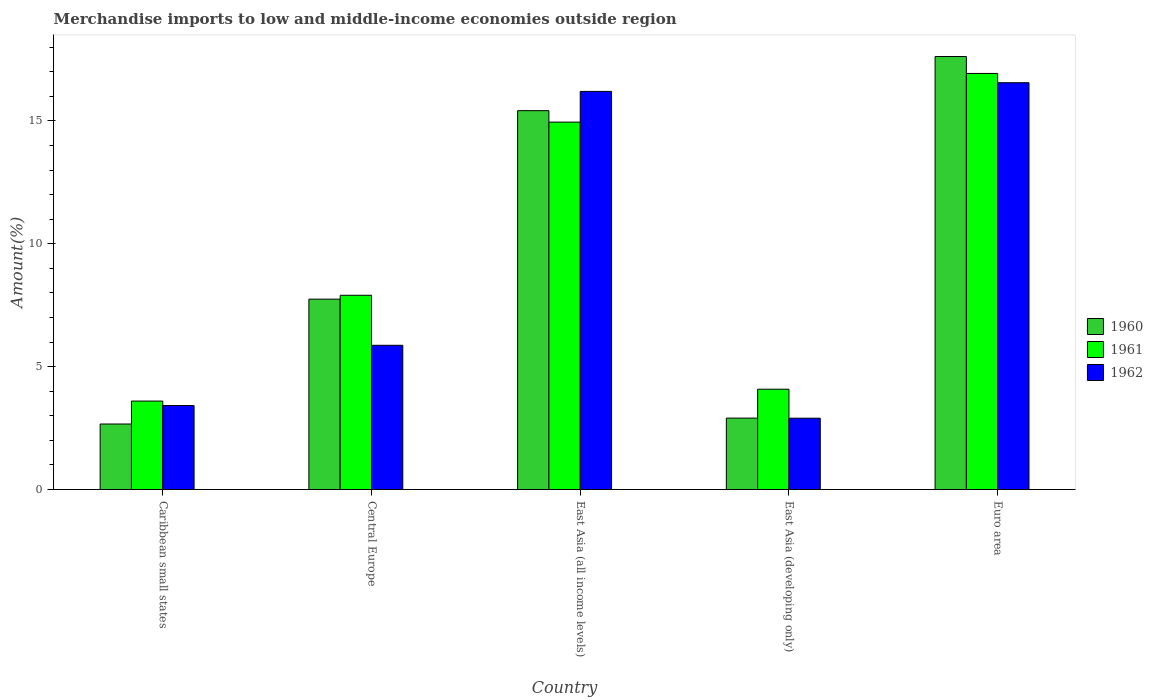How many different coloured bars are there?
Make the answer very short. 3. How many groups of bars are there?
Provide a succinct answer. 5. Are the number of bars per tick equal to the number of legend labels?
Offer a terse response. Yes. Are the number of bars on each tick of the X-axis equal?
Your answer should be very brief. Yes. How many bars are there on the 4th tick from the left?
Keep it short and to the point. 3. How many bars are there on the 3rd tick from the right?
Offer a terse response. 3. What is the label of the 3rd group of bars from the left?
Offer a very short reply. East Asia (all income levels). What is the percentage of amount earned from merchandise imports in 1962 in East Asia (all income levels)?
Offer a very short reply. 16.2. Across all countries, what is the maximum percentage of amount earned from merchandise imports in 1961?
Offer a very short reply. 16.93. Across all countries, what is the minimum percentage of amount earned from merchandise imports in 1960?
Give a very brief answer. 2.67. In which country was the percentage of amount earned from merchandise imports in 1960 minimum?
Provide a short and direct response. Caribbean small states. What is the total percentage of amount earned from merchandise imports in 1961 in the graph?
Offer a very short reply. 47.46. What is the difference between the percentage of amount earned from merchandise imports in 1960 in Caribbean small states and that in East Asia (all income levels)?
Provide a succinct answer. -12.75. What is the difference between the percentage of amount earned from merchandise imports in 1961 in East Asia (developing only) and the percentage of amount earned from merchandise imports in 1962 in East Asia (all income levels)?
Ensure brevity in your answer.  -12.12. What is the average percentage of amount earned from merchandise imports in 1961 per country?
Provide a succinct answer. 9.49. What is the difference between the percentage of amount earned from merchandise imports of/in 1962 and percentage of amount earned from merchandise imports of/in 1961 in East Asia (developing only)?
Provide a short and direct response. -1.18. What is the ratio of the percentage of amount earned from merchandise imports in 1962 in East Asia (developing only) to that in Euro area?
Provide a succinct answer. 0.18. Is the percentage of amount earned from merchandise imports in 1960 in Caribbean small states less than that in East Asia (all income levels)?
Offer a very short reply. Yes. Is the difference between the percentage of amount earned from merchandise imports in 1962 in Caribbean small states and Central Europe greater than the difference between the percentage of amount earned from merchandise imports in 1961 in Caribbean small states and Central Europe?
Provide a short and direct response. Yes. What is the difference between the highest and the second highest percentage of amount earned from merchandise imports in 1962?
Your response must be concise. 0.35. What is the difference between the highest and the lowest percentage of amount earned from merchandise imports in 1960?
Make the answer very short. 14.95. What does the 2nd bar from the right in Central Europe represents?
Keep it short and to the point. 1961. Is it the case that in every country, the sum of the percentage of amount earned from merchandise imports in 1960 and percentage of amount earned from merchandise imports in 1962 is greater than the percentage of amount earned from merchandise imports in 1961?
Provide a short and direct response. Yes. How many bars are there?
Provide a succinct answer. 15. What is the difference between two consecutive major ticks on the Y-axis?
Ensure brevity in your answer.  5. How are the legend labels stacked?
Offer a terse response. Vertical. What is the title of the graph?
Keep it short and to the point. Merchandise imports to low and middle-income economies outside region. Does "2006" appear as one of the legend labels in the graph?
Make the answer very short. No. What is the label or title of the Y-axis?
Provide a succinct answer. Amount(%). What is the Amount(%) of 1960 in Caribbean small states?
Offer a terse response. 2.67. What is the Amount(%) in 1961 in Caribbean small states?
Your answer should be very brief. 3.6. What is the Amount(%) of 1962 in Caribbean small states?
Give a very brief answer. 3.42. What is the Amount(%) of 1960 in Central Europe?
Ensure brevity in your answer.  7.75. What is the Amount(%) in 1961 in Central Europe?
Make the answer very short. 7.9. What is the Amount(%) in 1962 in Central Europe?
Give a very brief answer. 5.87. What is the Amount(%) of 1960 in East Asia (all income levels)?
Make the answer very short. 15.41. What is the Amount(%) of 1961 in East Asia (all income levels)?
Your response must be concise. 14.95. What is the Amount(%) of 1962 in East Asia (all income levels)?
Your response must be concise. 16.2. What is the Amount(%) of 1960 in East Asia (developing only)?
Keep it short and to the point. 2.91. What is the Amount(%) in 1961 in East Asia (developing only)?
Your answer should be very brief. 4.08. What is the Amount(%) of 1962 in East Asia (developing only)?
Provide a succinct answer. 2.9. What is the Amount(%) of 1960 in Euro area?
Provide a short and direct response. 17.62. What is the Amount(%) in 1961 in Euro area?
Your answer should be compact. 16.93. What is the Amount(%) in 1962 in Euro area?
Give a very brief answer. 16.55. Across all countries, what is the maximum Amount(%) of 1960?
Provide a short and direct response. 17.62. Across all countries, what is the maximum Amount(%) in 1961?
Ensure brevity in your answer.  16.93. Across all countries, what is the maximum Amount(%) in 1962?
Give a very brief answer. 16.55. Across all countries, what is the minimum Amount(%) in 1960?
Offer a very short reply. 2.67. Across all countries, what is the minimum Amount(%) of 1961?
Make the answer very short. 3.6. Across all countries, what is the minimum Amount(%) of 1962?
Offer a very short reply. 2.9. What is the total Amount(%) of 1960 in the graph?
Offer a very short reply. 46.35. What is the total Amount(%) in 1961 in the graph?
Your answer should be compact. 47.46. What is the total Amount(%) in 1962 in the graph?
Offer a very short reply. 44.94. What is the difference between the Amount(%) in 1960 in Caribbean small states and that in Central Europe?
Your answer should be compact. -5.08. What is the difference between the Amount(%) of 1961 in Caribbean small states and that in Central Europe?
Provide a succinct answer. -4.3. What is the difference between the Amount(%) of 1962 in Caribbean small states and that in Central Europe?
Provide a succinct answer. -2.45. What is the difference between the Amount(%) of 1960 in Caribbean small states and that in East Asia (all income levels)?
Make the answer very short. -12.75. What is the difference between the Amount(%) of 1961 in Caribbean small states and that in East Asia (all income levels)?
Your response must be concise. -11.35. What is the difference between the Amount(%) of 1962 in Caribbean small states and that in East Asia (all income levels)?
Ensure brevity in your answer.  -12.78. What is the difference between the Amount(%) in 1960 in Caribbean small states and that in East Asia (developing only)?
Your answer should be compact. -0.24. What is the difference between the Amount(%) of 1961 in Caribbean small states and that in East Asia (developing only)?
Give a very brief answer. -0.48. What is the difference between the Amount(%) in 1962 in Caribbean small states and that in East Asia (developing only)?
Make the answer very short. 0.52. What is the difference between the Amount(%) of 1960 in Caribbean small states and that in Euro area?
Provide a succinct answer. -14.95. What is the difference between the Amount(%) in 1961 in Caribbean small states and that in Euro area?
Offer a terse response. -13.33. What is the difference between the Amount(%) in 1962 in Caribbean small states and that in Euro area?
Provide a succinct answer. -13.13. What is the difference between the Amount(%) in 1960 in Central Europe and that in East Asia (all income levels)?
Provide a succinct answer. -7.67. What is the difference between the Amount(%) of 1961 in Central Europe and that in East Asia (all income levels)?
Keep it short and to the point. -7.05. What is the difference between the Amount(%) of 1962 in Central Europe and that in East Asia (all income levels)?
Offer a very short reply. -10.33. What is the difference between the Amount(%) in 1960 in Central Europe and that in East Asia (developing only)?
Your response must be concise. 4.84. What is the difference between the Amount(%) in 1961 in Central Europe and that in East Asia (developing only)?
Offer a very short reply. 3.82. What is the difference between the Amount(%) in 1962 in Central Europe and that in East Asia (developing only)?
Your answer should be compact. 2.97. What is the difference between the Amount(%) of 1960 in Central Europe and that in Euro area?
Provide a succinct answer. -9.87. What is the difference between the Amount(%) of 1961 in Central Europe and that in Euro area?
Ensure brevity in your answer.  -9.03. What is the difference between the Amount(%) in 1962 in Central Europe and that in Euro area?
Ensure brevity in your answer.  -10.68. What is the difference between the Amount(%) in 1960 in East Asia (all income levels) and that in East Asia (developing only)?
Provide a short and direct response. 12.51. What is the difference between the Amount(%) in 1961 in East Asia (all income levels) and that in East Asia (developing only)?
Give a very brief answer. 10.87. What is the difference between the Amount(%) of 1962 in East Asia (all income levels) and that in East Asia (developing only)?
Your answer should be compact. 13.3. What is the difference between the Amount(%) of 1960 in East Asia (all income levels) and that in Euro area?
Your answer should be very brief. -2.2. What is the difference between the Amount(%) in 1961 in East Asia (all income levels) and that in Euro area?
Offer a terse response. -1.98. What is the difference between the Amount(%) of 1962 in East Asia (all income levels) and that in Euro area?
Your answer should be very brief. -0.35. What is the difference between the Amount(%) in 1960 in East Asia (developing only) and that in Euro area?
Make the answer very short. -14.71. What is the difference between the Amount(%) in 1961 in East Asia (developing only) and that in Euro area?
Keep it short and to the point. -12.85. What is the difference between the Amount(%) in 1962 in East Asia (developing only) and that in Euro area?
Keep it short and to the point. -13.65. What is the difference between the Amount(%) of 1960 in Caribbean small states and the Amount(%) of 1961 in Central Europe?
Provide a short and direct response. -5.24. What is the difference between the Amount(%) in 1960 in Caribbean small states and the Amount(%) in 1962 in Central Europe?
Provide a succinct answer. -3.2. What is the difference between the Amount(%) in 1961 in Caribbean small states and the Amount(%) in 1962 in Central Europe?
Your response must be concise. -2.27. What is the difference between the Amount(%) in 1960 in Caribbean small states and the Amount(%) in 1961 in East Asia (all income levels)?
Your answer should be compact. -12.28. What is the difference between the Amount(%) of 1960 in Caribbean small states and the Amount(%) of 1962 in East Asia (all income levels)?
Make the answer very short. -13.53. What is the difference between the Amount(%) in 1961 in Caribbean small states and the Amount(%) in 1962 in East Asia (all income levels)?
Your answer should be compact. -12.6. What is the difference between the Amount(%) in 1960 in Caribbean small states and the Amount(%) in 1961 in East Asia (developing only)?
Provide a short and direct response. -1.42. What is the difference between the Amount(%) in 1960 in Caribbean small states and the Amount(%) in 1962 in East Asia (developing only)?
Your response must be concise. -0.24. What is the difference between the Amount(%) in 1961 in Caribbean small states and the Amount(%) in 1962 in East Asia (developing only)?
Keep it short and to the point. 0.7. What is the difference between the Amount(%) in 1960 in Caribbean small states and the Amount(%) in 1961 in Euro area?
Ensure brevity in your answer.  -14.26. What is the difference between the Amount(%) in 1960 in Caribbean small states and the Amount(%) in 1962 in Euro area?
Make the answer very short. -13.89. What is the difference between the Amount(%) of 1961 in Caribbean small states and the Amount(%) of 1962 in Euro area?
Make the answer very short. -12.95. What is the difference between the Amount(%) in 1960 in Central Europe and the Amount(%) in 1961 in East Asia (all income levels)?
Your response must be concise. -7.2. What is the difference between the Amount(%) of 1960 in Central Europe and the Amount(%) of 1962 in East Asia (all income levels)?
Keep it short and to the point. -8.45. What is the difference between the Amount(%) in 1961 in Central Europe and the Amount(%) in 1962 in East Asia (all income levels)?
Offer a very short reply. -8.3. What is the difference between the Amount(%) in 1960 in Central Europe and the Amount(%) in 1961 in East Asia (developing only)?
Keep it short and to the point. 3.66. What is the difference between the Amount(%) in 1960 in Central Europe and the Amount(%) in 1962 in East Asia (developing only)?
Your response must be concise. 4.84. What is the difference between the Amount(%) in 1961 in Central Europe and the Amount(%) in 1962 in East Asia (developing only)?
Ensure brevity in your answer.  5. What is the difference between the Amount(%) of 1960 in Central Europe and the Amount(%) of 1961 in Euro area?
Make the answer very short. -9.18. What is the difference between the Amount(%) in 1960 in Central Europe and the Amount(%) in 1962 in Euro area?
Your response must be concise. -8.81. What is the difference between the Amount(%) in 1961 in Central Europe and the Amount(%) in 1962 in Euro area?
Give a very brief answer. -8.65. What is the difference between the Amount(%) in 1960 in East Asia (all income levels) and the Amount(%) in 1961 in East Asia (developing only)?
Ensure brevity in your answer.  11.33. What is the difference between the Amount(%) of 1960 in East Asia (all income levels) and the Amount(%) of 1962 in East Asia (developing only)?
Your answer should be very brief. 12.51. What is the difference between the Amount(%) of 1961 in East Asia (all income levels) and the Amount(%) of 1962 in East Asia (developing only)?
Give a very brief answer. 12.05. What is the difference between the Amount(%) in 1960 in East Asia (all income levels) and the Amount(%) in 1961 in Euro area?
Your response must be concise. -1.51. What is the difference between the Amount(%) in 1960 in East Asia (all income levels) and the Amount(%) in 1962 in Euro area?
Ensure brevity in your answer.  -1.14. What is the difference between the Amount(%) in 1961 in East Asia (all income levels) and the Amount(%) in 1962 in Euro area?
Offer a very short reply. -1.6. What is the difference between the Amount(%) in 1960 in East Asia (developing only) and the Amount(%) in 1961 in Euro area?
Give a very brief answer. -14.02. What is the difference between the Amount(%) of 1960 in East Asia (developing only) and the Amount(%) of 1962 in Euro area?
Your answer should be compact. -13.65. What is the difference between the Amount(%) in 1961 in East Asia (developing only) and the Amount(%) in 1962 in Euro area?
Ensure brevity in your answer.  -12.47. What is the average Amount(%) of 1960 per country?
Your answer should be compact. 9.27. What is the average Amount(%) of 1961 per country?
Offer a very short reply. 9.49. What is the average Amount(%) in 1962 per country?
Provide a short and direct response. 8.99. What is the difference between the Amount(%) of 1960 and Amount(%) of 1961 in Caribbean small states?
Make the answer very short. -0.93. What is the difference between the Amount(%) in 1960 and Amount(%) in 1962 in Caribbean small states?
Your answer should be very brief. -0.75. What is the difference between the Amount(%) of 1961 and Amount(%) of 1962 in Caribbean small states?
Your response must be concise. 0.18. What is the difference between the Amount(%) in 1960 and Amount(%) in 1961 in Central Europe?
Ensure brevity in your answer.  -0.16. What is the difference between the Amount(%) in 1960 and Amount(%) in 1962 in Central Europe?
Provide a short and direct response. 1.88. What is the difference between the Amount(%) in 1961 and Amount(%) in 1962 in Central Europe?
Make the answer very short. 2.03. What is the difference between the Amount(%) in 1960 and Amount(%) in 1961 in East Asia (all income levels)?
Your response must be concise. 0.47. What is the difference between the Amount(%) of 1960 and Amount(%) of 1962 in East Asia (all income levels)?
Offer a very short reply. -0.78. What is the difference between the Amount(%) in 1961 and Amount(%) in 1962 in East Asia (all income levels)?
Your answer should be compact. -1.25. What is the difference between the Amount(%) in 1960 and Amount(%) in 1961 in East Asia (developing only)?
Keep it short and to the point. -1.18. What is the difference between the Amount(%) in 1960 and Amount(%) in 1962 in East Asia (developing only)?
Offer a very short reply. 0. What is the difference between the Amount(%) in 1961 and Amount(%) in 1962 in East Asia (developing only)?
Offer a terse response. 1.18. What is the difference between the Amount(%) in 1960 and Amount(%) in 1961 in Euro area?
Your answer should be very brief. 0.69. What is the difference between the Amount(%) in 1960 and Amount(%) in 1962 in Euro area?
Your response must be concise. 1.07. What is the difference between the Amount(%) in 1961 and Amount(%) in 1962 in Euro area?
Give a very brief answer. 0.38. What is the ratio of the Amount(%) in 1960 in Caribbean small states to that in Central Europe?
Ensure brevity in your answer.  0.34. What is the ratio of the Amount(%) of 1961 in Caribbean small states to that in Central Europe?
Your answer should be very brief. 0.46. What is the ratio of the Amount(%) in 1962 in Caribbean small states to that in Central Europe?
Your answer should be very brief. 0.58. What is the ratio of the Amount(%) of 1960 in Caribbean small states to that in East Asia (all income levels)?
Give a very brief answer. 0.17. What is the ratio of the Amount(%) in 1961 in Caribbean small states to that in East Asia (all income levels)?
Ensure brevity in your answer.  0.24. What is the ratio of the Amount(%) of 1962 in Caribbean small states to that in East Asia (all income levels)?
Your response must be concise. 0.21. What is the ratio of the Amount(%) of 1960 in Caribbean small states to that in East Asia (developing only)?
Provide a short and direct response. 0.92. What is the ratio of the Amount(%) in 1961 in Caribbean small states to that in East Asia (developing only)?
Your answer should be compact. 0.88. What is the ratio of the Amount(%) of 1962 in Caribbean small states to that in East Asia (developing only)?
Keep it short and to the point. 1.18. What is the ratio of the Amount(%) of 1960 in Caribbean small states to that in Euro area?
Your response must be concise. 0.15. What is the ratio of the Amount(%) of 1961 in Caribbean small states to that in Euro area?
Your response must be concise. 0.21. What is the ratio of the Amount(%) of 1962 in Caribbean small states to that in Euro area?
Give a very brief answer. 0.21. What is the ratio of the Amount(%) of 1960 in Central Europe to that in East Asia (all income levels)?
Offer a very short reply. 0.5. What is the ratio of the Amount(%) in 1961 in Central Europe to that in East Asia (all income levels)?
Offer a very short reply. 0.53. What is the ratio of the Amount(%) of 1962 in Central Europe to that in East Asia (all income levels)?
Give a very brief answer. 0.36. What is the ratio of the Amount(%) of 1960 in Central Europe to that in East Asia (developing only)?
Provide a short and direct response. 2.67. What is the ratio of the Amount(%) of 1961 in Central Europe to that in East Asia (developing only)?
Your answer should be very brief. 1.94. What is the ratio of the Amount(%) in 1962 in Central Europe to that in East Asia (developing only)?
Offer a terse response. 2.02. What is the ratio of the Amount(%) in 1960 in Central Europe to that in Euro area?
Ensure brevity in your answer.  0.44. What is the ratio of the Amount(%) of 1961 in Central Europe to that in Euro area?
Give a very brief answer. 0.47. What is the ratio of the Amount(%) of 1962 in Central Europe to that in Euro area?
Ensure brevity in your answer.  0.35. What is the ratio of the Amount(%) in 1960 in East Asia (all income levels) to that in East Asia (developing only)?
Make the answer very short. 5.3. What is the ratio of the Amount(%) in 1961 in East Asia (all income levels) to that in East Asia (developing only)?
Keep it short and to the point. 3.66. What is the ratio of the Amount(%) of 1962 in East Asia (all income levels) to that in East Asia (developing only)?
Keep it short and to the point. 5.58. What is the ratio of the Amount(%) in 1960 in East Asia (all income levels) to that in Euro area?
Offer a very short reply. 0.88. What is the ratio of the Amount(%) of 1961 in East Asia (all income levels) to that in Euro area?
Your response must be concise. 0.88. What is the ratio of the Amount(%) of 1962 in East Asia (all income levels) to that in Euro area?
Provide a short and direct response. 0.98. What is the ratio of the Amount(%) of 1960 in East Asia (developing only) to that in Euro area?
Make the answer very short. 0.16. What is the ratio of the Amount(%) of 1961 in East Asia (developing only) to that in Euro area?
Offer a very short reply. 0.24. What is the ratio of the Amount(%) in 1962 in East Asia (developing only) to that in Euro area?
Make the answer very short. 0.18. What is the difference between the highest and the second highest Amount(%) in 1960?
Provide a short and direct response. 2.2. What is the difference between the highest and the second highest Amount(%) in 1961?
Give a very brief answer. 1.98. What is the difference between the highest and the second highest Amount(%) of 1962?
Give a very brief answer. 0.35. What is the difference between the highest and the lowest Amount(%) in 1960?
Give a very brief answer. 14.95. What is the difference between the highest and the lowest Amount(%) of 1961?
Your response must be concise. 13.33. What is the difference between the highest and the lowest Amount(%) of 1962?
Offer a very short reply. 13.65. 